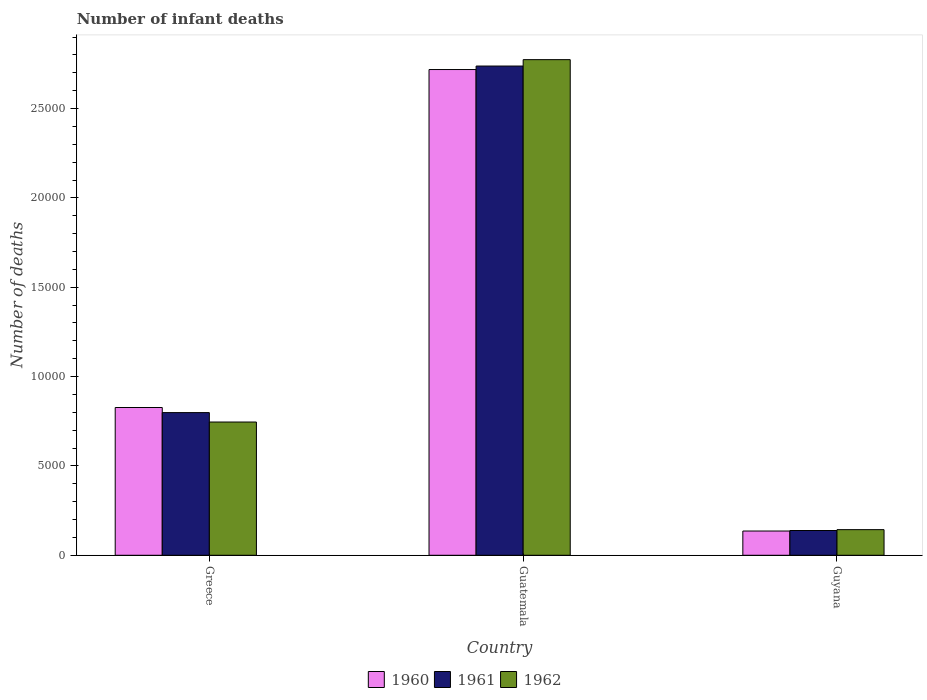How many different coloured bars are there?
Your answer should be compact. 3. Are the number of bars per tick equal to the number of legend labels?
Your response must be concise. Yes. How many bars are there on the 1st tick from the left?
Your response must be concise. 3. What is the label of the 3rd group of bars from the left?
Ensure brevity in your answer.  Guyana. What is the number of infant deaths in 1960 in Greece?
Your answer should be very brief. 8269. Across all countries, what is the maximum number of infant deaths in 1962?
Offer a terse response. 2.77e+04. Across all countries, what is the minimum number of infant deaths in 1960?
Offer a terse response. 1357. In which country was the number of infant deaths in 1962 maximum?
Offer a very short reply. Guatemala. In which country was the number of infant deaths in 1961 minimum?
Offer a very short reply. Guyana. What is the total number of infant deaths in 1960 in the graph?
Provide a short and direct response. 3.68e+04. What is the difference between the number of infant deaths in 1961 in Greece and that in Guatemala?
Make the answer very short. -1.94e+04. What is the difference between the number of infant deaths in 1961 in Guatemala and the number of infant deaths in 1960 in Greece?
Provide a short and direct response. 1.91e+04. What is the average number of infant deaths in 1962 per country?
Your response must be concise. 1.22e+04. What is the difference between the number of infant deaths of/in 1961 and number of infant deaths of/in 1960 in Greece?
Offer a terse response. -285. In how many countries, is the number of infant deaths in 1961 greater than 24000?
Make the answer very short. 1. What is the ratio of the number of infant deaths in 1960 in Greece to that in Guyana?
Ensure brevity in your answer.  6.09. Is the number of infant deaths in 1961 in Greece less than that in Guyana?
Provide a short and direct response. No. What is the difference between the highest and the second highest number of infant deaths in 1960?
Provide a short and direct response. -6912. What is the difference between the highest and the lowest number of infant deaths in 1961?
Your response must be concise. 2.60e+04. Is the sum of the number of infant deaths in 1960 in Guatemala and Guyana greater than the maximum number of infant deaths in 1961 across all countries?
Offer a terse response. Yes. Is it the case that in every country, the sum of the number of infant deaths in 1960 and number of infant deaths in 1961 is greater than the number of infant deaths in 1962?
Offer a terse response. Yes. How many bars are there?
Keep it short and to the point. 9. Are the values on the major ticks of Y-axis written in scientific E-notation?
Your answer should be very brief. No. Does the graph contain any zero values?
Your answer should be compact. No. How are the legend labels stacked?
Your answer should be very brief. Horizontal. What is the title of the graph?
Offer a very short reply. Number of infant deaths. Does "1978" appear as one of the legend labels in the graph?
Offer a very short reply. No. What is the label or title of the Y-axis?
Give a very brief answer. Number of deaths. What is the Number of deaths of 1960 in Greece?
Your answer should be very brief. 8269. What is the Number of deaths of 1961 in Greece?
Give a very brief answer. 7984. What is the Number of deaths of 1962 in Greece?
Make the answer very short. 7457. What is the Number of deaths of 1960 in Guatemala?
Provide a succinct answer. 2.72e+04. What is the Number of deaths in 1961 in Guatemala?
Your answer should be very brief. 2.74e+04. What is the Number of deaths in 1962 in Guatemala?
Keep it short and to the point. 2.77e+04. What is the Number of deaths in 1960 in Guyana?
Give a very brief answer. 1357. What is the Number of deaths in 1961 in Guyana?
Your answer should be compact. 1386. What is the Number of deaths in 1962 in Guyana?
Make the answer very short. 1434. Across all countries, what is the maximum Number of deaths of 1960?
Offer a terse response. 2.72e+04. Across all countries, what is the maximum Number of deaths in 1961?
Provide a short and direct response. 2.74e+04. Across all countries, what is the maximum Number of deaths in 1962?
Your answer should be compact. 2.77e+04. Across all countries, what is the minimum Number of deaths in 1960?
Ensure brevity in your answer.  1357. Across all countries, what is the minimum Number of deaths in 1961?
Provide a short and direct response. 1386. Across all countries, what is the minimum Number of deaths in 1962?
Your answer should be very brief. 1434. What is the total Number of deaths in 1960 in the graph?
Keep it short and to the point. 3.68e+04. What is the total Number of deaths in 1961 in the graph?
Provide a short and direct response. 3.67e+04. What is the total Number of deaths in 1962 in the graph?
Offer a very short reply. 3.66e+04. What is the difference between the Number of deaths in 1960 in Greece and that in Guatemala?
Ensure brevity in your answer.  -1.89e+04. What is the difference between the Number of deaths in 1961 in Greece and that in Guatemala?
Ensure brevity in your answer.  -1.94e+04. What is the difference between the Number of deaths in 1962 in Greece and that in Guatemala?
Ensure brevity in your answer.  -2.03e+04. What is the difference between the Number of deaths of 1960 in Greece and that in Guyana?
Provide a short and direct response. 6912. What is the difference between the Number of deaths in 1961 in Greece and that in Guyana?
Ensure brevity in your answer.  6598. What is the difference between the Number of deaths of 1962 in Greece and that in Guyana?
Offer a very short reply. 6023. What is the difference between the Number of deaths of 1960 in Guatemala and that in Guyana?
Give a very brief answer. 2.58e+04. What is the difference between the Number of deaths in 1961 in Guatemala and that in Guyana?
Provide a short and direct response. 2.60e+04. What is the difference between the Number of deaths in 1962 in Guatemala and that in Guyana?
Offer a terse response. 2.63e+04. What is the difference between the Number of deaths in 1960 in Greece and the Number of deaths in 1961 in Guatemala?
Your response must be concise. -1.91e+04. What is the difference between the Number of deaths of 1960 in Greece and the Number of deaths of 1962 in Guatemala?
Your answer should be very brief. -1.95e+04. What is the difference between the Number of deaths in 1961 in Greece and the Number of deaths in 1962 in Guatemala?
Provide a short and direct response. -1.98e+04. What is the difference between the Number of deaths in 1960 in Greece and the Number of deaths in 1961 in Guyana?
Keep it short and to the point. 6883. What is the difference between the Number of deaths in 1960 in Greece and the Number of deaths in 1962 in Guyana?
Make the answer very short. 6835. What is the difference between the Number of deaths of 1961 in Greece and the Number of deaths of 1962 in Guyana?
Offer a very short reply. 6550. What is the difference between the Number of deaths in 1960 in Guatemala and the Number of deaths in 1961 in Guyana?
Ensure brevity in your answer.  2.58e+04. What is the difference between the Number of deaths in 1960 in Guatemala and the Number of deaths in 1962 in Guyana?
Your answer should be compact. 2.57e+04. What is the difference between the Number of deaths of 1961 in Guatemala and the Number of deaths of 1962 in Guyana?
Give a very brief answer. 2.59e+04. What is the average Number of deaths in 1960 per country?
Your answer should be very brief. 1.23e+04. What is the average Number of deaths in 1961 per country?
Give a very brief answer. 1.22e+04. What is the average Number of deaths of 1962 per country?
Your answer should be compact. 1.22e+04. What is the difference between the Number of deaths in 1960 and Number of deaths in 1961 in Greece?
Ensure brevity in your answer.  285. What is the difference between the Number of deaths in 1960 and Number of deaths in 1962 in Greece?
Give a very brief answer. 812. What is the difference between the Number of deaths in 1961 and Number of deaths in 1962 in Greece?
Your answer should be very brief. 527. What is the difference between the Number of deaths of 1960 and Number of deaths of 1961 in Guatemala?
Your answer should be compact. -196. What is the difference between the Number of deaths in 1960 and Number of deaths in 1962 in Guatemala?
Keep it short and to the point. -553. What is the difference between the Number of deaths in 1961 and Number of deaths in 1962 in Guatemala?
Ensure brevity in your answer.  -357. What is the difference between the Number of deaths of 1960 and Number of deaths of 1961 in Guyana?
Your answer should be compact. -29. What is the difference between the Number of deaths of 1960 and Number of deaths of 1962 in Guyana?
Offer a very short reply. -77. What is the difference between the Number of deaths of 1961 and Number of deaths of 1962 in Guyana?
Your answer should be very brief. -48. What is the ratio of the Number of deaths of 1960 in Greece to that in Guatemala?
Your answer should be very brief. 0.3. What is the ratio of the Number of deaths in 1961 in Greece to that in Guatemala?
Provide a short and direct response. 0.29. What is the ratio of the Number of deaths in 1962 in Greece to that in Guatemala?
Ensure brevity in your answer.  0.27. What is the ratio of the Number of deaths of 1960 in Greece to that in Guyana?
Your answer should be compact. 6.09. What is the ratio of the Number of deaths of 1961 in Greece to that in Guyana?
Offer a very short reply. 5.76. What is the ratio of the Number of deaths of 1962 in Greece to that in Guyana?
Provide a short and direct response. 5.2. What is the ratio of the Number of deaths of 1960 in Guatemala to that in Guyana?
Provide a short and direct response. 20.03. What is the ratio of the Number of deaths in 1961 in Guatemala to that in Guyana?
Keep it short and to the point. 19.75. What is the ratio of the Number of deaths in 1962 in Guatemala to that in Guyana?
Keep it short and to the point. 19.34. What is the difference between the highest and the second highest Number of deaths in 1960?
Your answer should be very brief. 1.89e+04. What is the difference between the highest and the second highest Number of deaths in 1961?
Offer a very short reply. 1.94e+04. What is the difference between the highest and the second highest Number of deaths of 1962?
Provide a succinct answer. 2.03e+04. What is the difference between the highest and the lowest Number of deaths in 1960?
Provide a short and direct response. 2.58e+04. What is the difference between the highest and the lowest Number of deaths in 1961?
Provide a short and direct response. 2.60e+04. What is the difference between the highest and the lowest Number of deaths in 1962?
Make the answer very short. 2.63e+04. 